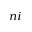<formula> <loc_0><loc_0><loc_500><loc_500>_ { n i }</formula> 